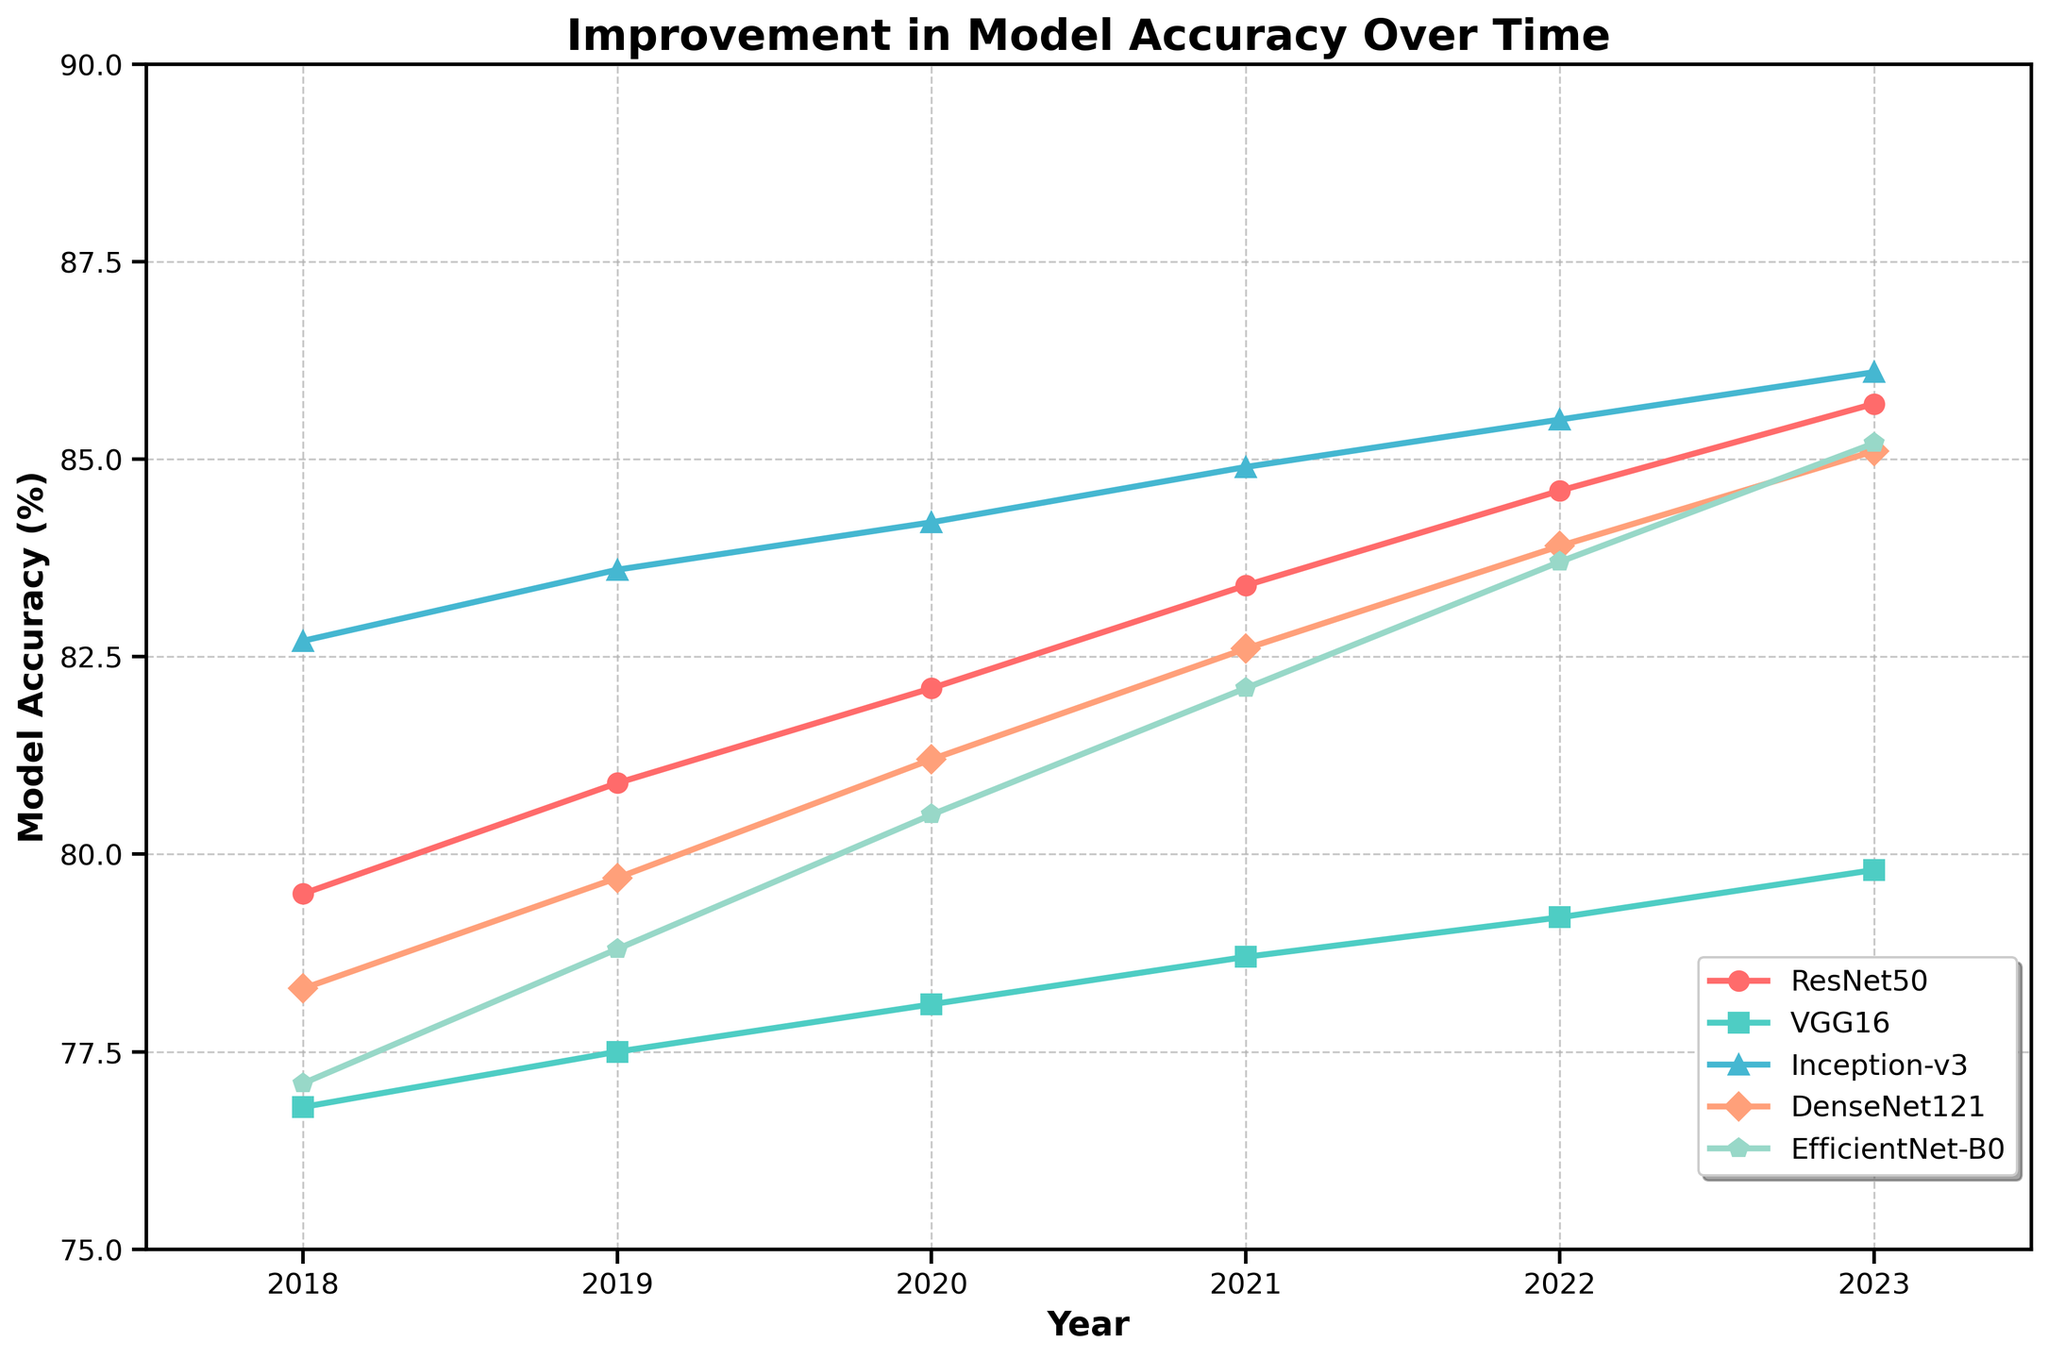What is the model with the highest accuracy in 2023? Check the 2023 values for all models in the chart. Inception-v3 has the highest accuracy in 2023 with 86.1%.
Answer: Inception-v3 Which model shows the most significant improvement in accuracy from 2018 to 2023? Calculate the difference in accuracy from 2018 to 2023 for each model and compare. ResNet50 shows the most significant improvement with an increase of 6.2% (85.7% - 79.5%).
Answer: ResNet50 How much did DenseNet121 improve from 2020 to 2022? Look at the values for DenseNet121 in 2020 and 2022. The improvement is 83.9% - 81.2% = 2.7%.
Answer: 2.7% Which two models have the closest accuracy values in 2021? Compare the accuracy values of all models in 2021. EfficientNet-B0 and DenseNet121 have the closest values at 82.1% and 82.6%, respectively.
Answer: EfficientNet-B0 and DenseNet121 What is the average accuracy of VGG16 from 2018 to 2023? Sum the accuracies of VGG16 from 2018 to 2023 and divide by the number of years. The average is (76.8 + 77.5 + 78.1 + 78.7 + 79.2 + 79.8) / 6 = 78.35%.
Answer: 78.35% Which model had the lowest accuracy in 2018? Look at the values for all models in 2018. VGG16 had the lowest accuracy at 76.8%.
Answer: VGG16 What is the total improvement in accuracy for EfficientNet-B0 from 2018 to 2023? The improvement is the difference between 2023 and 2018 values: 85.2% - 77.1% = 8.1%.
Answer: 8.1% Did any model’s accuracy decrease in any year from 2018 to 2023? Check the trend for each model year by year. No models show a decrease in accuracy any year; their values either increased or remained stable.
Answer: No Which model consistently showed an increase in accuracy every year? Review the yearly accuracy values for each model. All models consistently showed an increase in accuracy every year from 2018 to 2023.
Answer: All models How does ResNet50’s improvement compare with VGG16’s from 2018 to 2023? Calculate the improvement for both: ResNet50 (85.7% - 79.5% = 6.2%) and VGG16 (79.8% - 76.8% = 3.0%). ResNet50 improved by 6.2%, and VGG16 by 3.0%; hence, ResNet50 had a greater improvement.
Answer: ResNet50 improved more than VGG16 